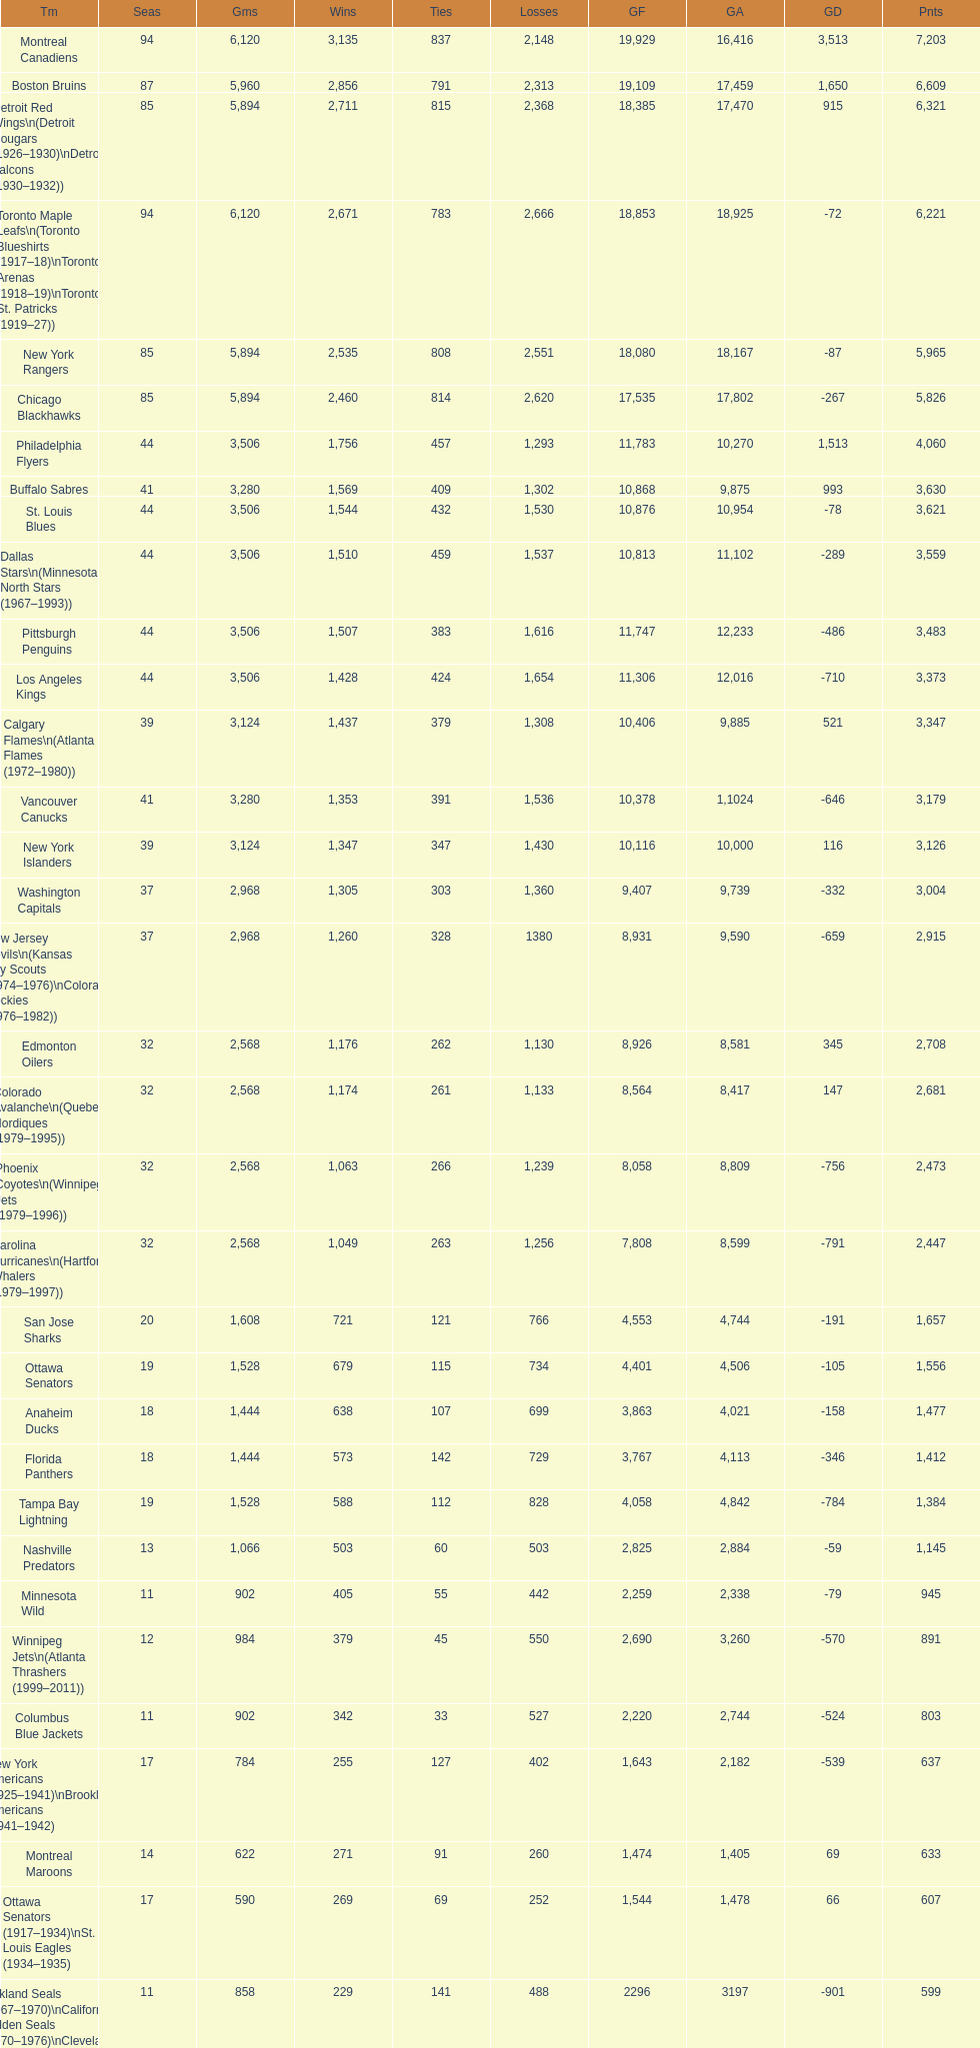How many total points has the lost angeles kings scored? 3,373. 